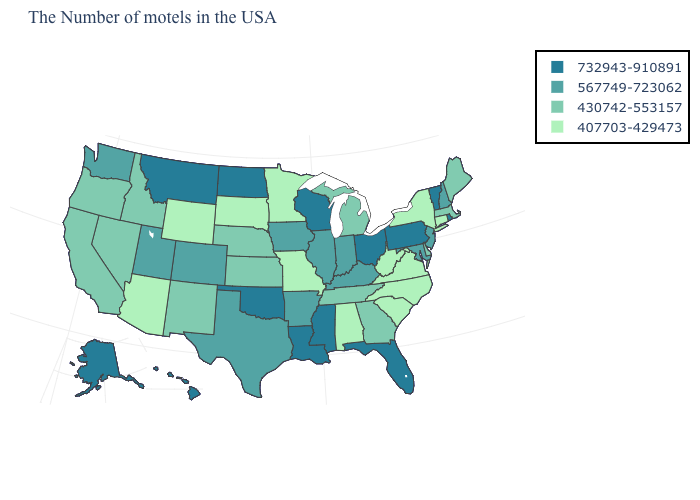Which states have the highest value in the USA?
Concise answer only. Rhode Island, Vermont, Pennsylvania, Ohio, Florida, Wisconsin, Mississippi, Louisiana, Oklahoma, North Dakota, Montana, Alaska, Hawaii. What is the value of Pennsylvania?
Quick response, please. 732943-910891. What is the value of Hawaii?
Be succinct. 732943-910891. What is the value of Kentucky?
Write a very short answer. 567749-723062. Name the states that have a value in the range 430742-553157?
Short answer required. Maine, Massachusetts, Delaware, Georgia, Michigan, Tennessee, Kansas, Nebraska, New Mexico, Idaho, Nevada, California, Oregon. What is the value of Idaho?
Be succinct. 430742-553157. Name the states that have a value in the range 407703-429473?
Keep it brief. Connecticut, New York, Virginia, North Carolina, South Carolina, West Virginia, Alabama, Missouri, Minnesota, South Dakota, Wyoming, Arizona. What is the value of Vermont?
Quick response, please. 732943-910891. Name the states that have a value in the range 732943-910891?
Short answer required. Rhode Island, Vermont, Pennsylvania, Ohio, Florida, Wisconsin, Mississippi, Louisiana, Oklahoma, North Dakota, Montana, Alaska, Hawaii. Does South Carolina have the lowest value in the USA?
Keep it brief. Yes. Does the first symbol in the legend represent the smallest category?
Keep it brief. No. Name the states that have a value in the range 732943-910891?
Write a very short answer. Rhode Island, Vermont, Pennsylvania, Ohio, Florida, Wisconsin, Mississippi, Louisiana, Oklahoma, North Dakota, Montana, Alaska, Hawaii. Name the states that have a value in the range 732943-910891?
Answer briefly. Rhode Island, Vermont, Pennsylvania, Ohio, Florida, Wisconsin, Mississippi, Louisiana, Oklahoma, North Dakota, Montana, Alaska, Hawaii. 